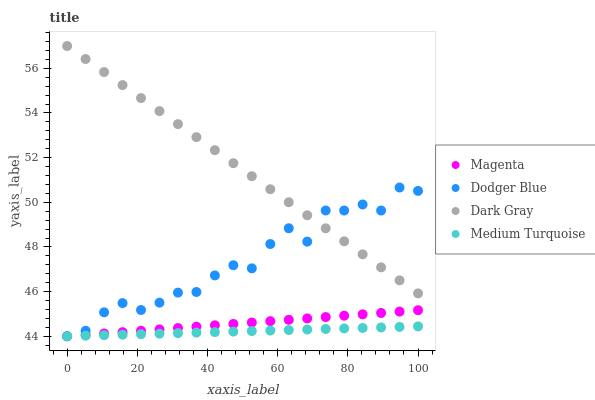Does Medium Turquoise have the minimum area under the curve?
Answer yes or no. Yes. Does Dark Gray have the maximum area under the curve?
Answer yes or no. Yes. Does Magenta have the minimum area under the curve?
Answer yes or no. No. Does Magenta have the maximum area under the curve?
Answer yes or no. No. Is Dark Gray the smoothest?
Answer yes or no. Yes. Is Dodger Blue the roughest?
Answer yes or no. Yes. Is Magenta the smoothest?
Answer yes or no. No. Is Magenta the roughest?
Answer yes or no. No. Does Magenta have the lowest value?
Answer yes or no. Yes. Does Dark Gray have the highest value?
Answer yes or no. Yes. Does Magenta have the highest value?
Answer yes or no. No. Is Medium Turquoise less than Dark Gray?
Answer yes or no. Yes. Is Dark Gray greater than Medium Turquoise?
Answer yes or no. Yes. Does Magenta intersect Medium Turquoise?
Answer yes or no. Yes. Is Magenta less than Medium Turquoise?
Answer yes or no. No. Is Magenta greater than Medium Turquoise?
Answer yes or no. No. Does Medium Turquoise intersect Dark Gray?
Answer yes or no. No. 